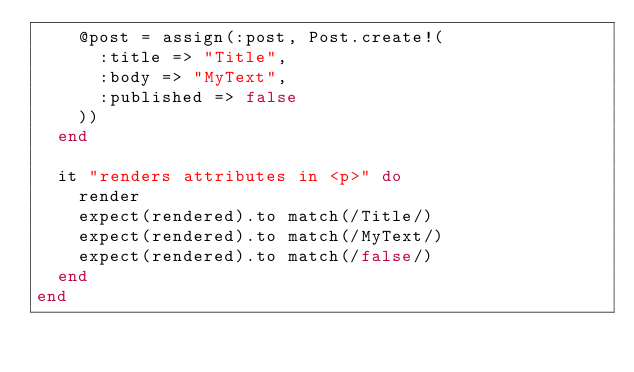Convert code to text. <code><loc_0><loc_0><loc_500><loc_500><_Ruby_>    @post = assign(:post, Post.create!(
      :title => "Title",
      :body => "MyText",
      :published => false
    ))
  end

  it "renders attributes in <p>" do
    render
    expect(rendered).to match(/Title/)
    expect(rendered).to match(/MyText/)
    expect(rendered).to match(/false/)
  end
end
</code> 